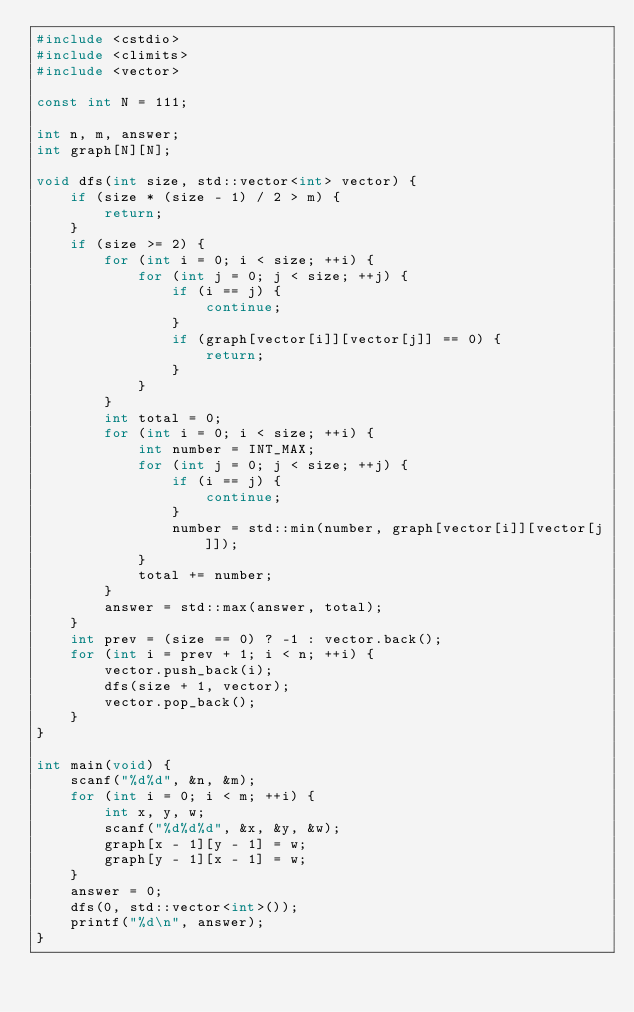Convert code to text. <code><loc_0><loc_0><loc_500><loc_500><_C++_>#include <cstdio>
#include <climits>
#include <vector>

const int N = 111;

int n, m, answer;
int graph[N][N];

void dfs(int size, std::vector<int> vector) {
    if (size * (size - 1) / 2 > m) {
        return;
    }
    if (size >= 2) {
        for (int i = 0; i < size; ++i) {
            for (int j = 0; j < size; ++j) {
                if (i == j) {
                    continue;
                }
                if (graph[vector[i]][vector[j]] == 0) {
                    return;
                }
            }
        }
        int total = 0;
        for (int i = 0; i < size; ++i) {
            int number = INT_MAX;
            for (int j = 0; j < size; ++j) {
                if (i == j) {
                    continue;
                }
                number = std::min(number, graph[vector[i]][vector[j]]);
            }
            total += number;
        }
        answer = std::max(answer, total);
    }
    int prev = (size == 0) ? -1 : vector.back();
    for (int i = prev + 1; i < n; ++i) {
        vector.push_back(i);
        dfs(size + 1, vector);
        vector.pop_back();
    }
}

int main(void) {
    scanf("%d%d", &n, &m);
    for (int i = 0; i < m; ++i) {
        int x, y, w;
        scanf("%d%d%d", &x, &y, &w);
        graph[x - 1][y - 1] = w;
        graph[y - 1][x - 1] = w;
    }
    answer = 0;
    dfs(0, std::vector<int>());
    printf("%d\n", answer);
}
</code> 